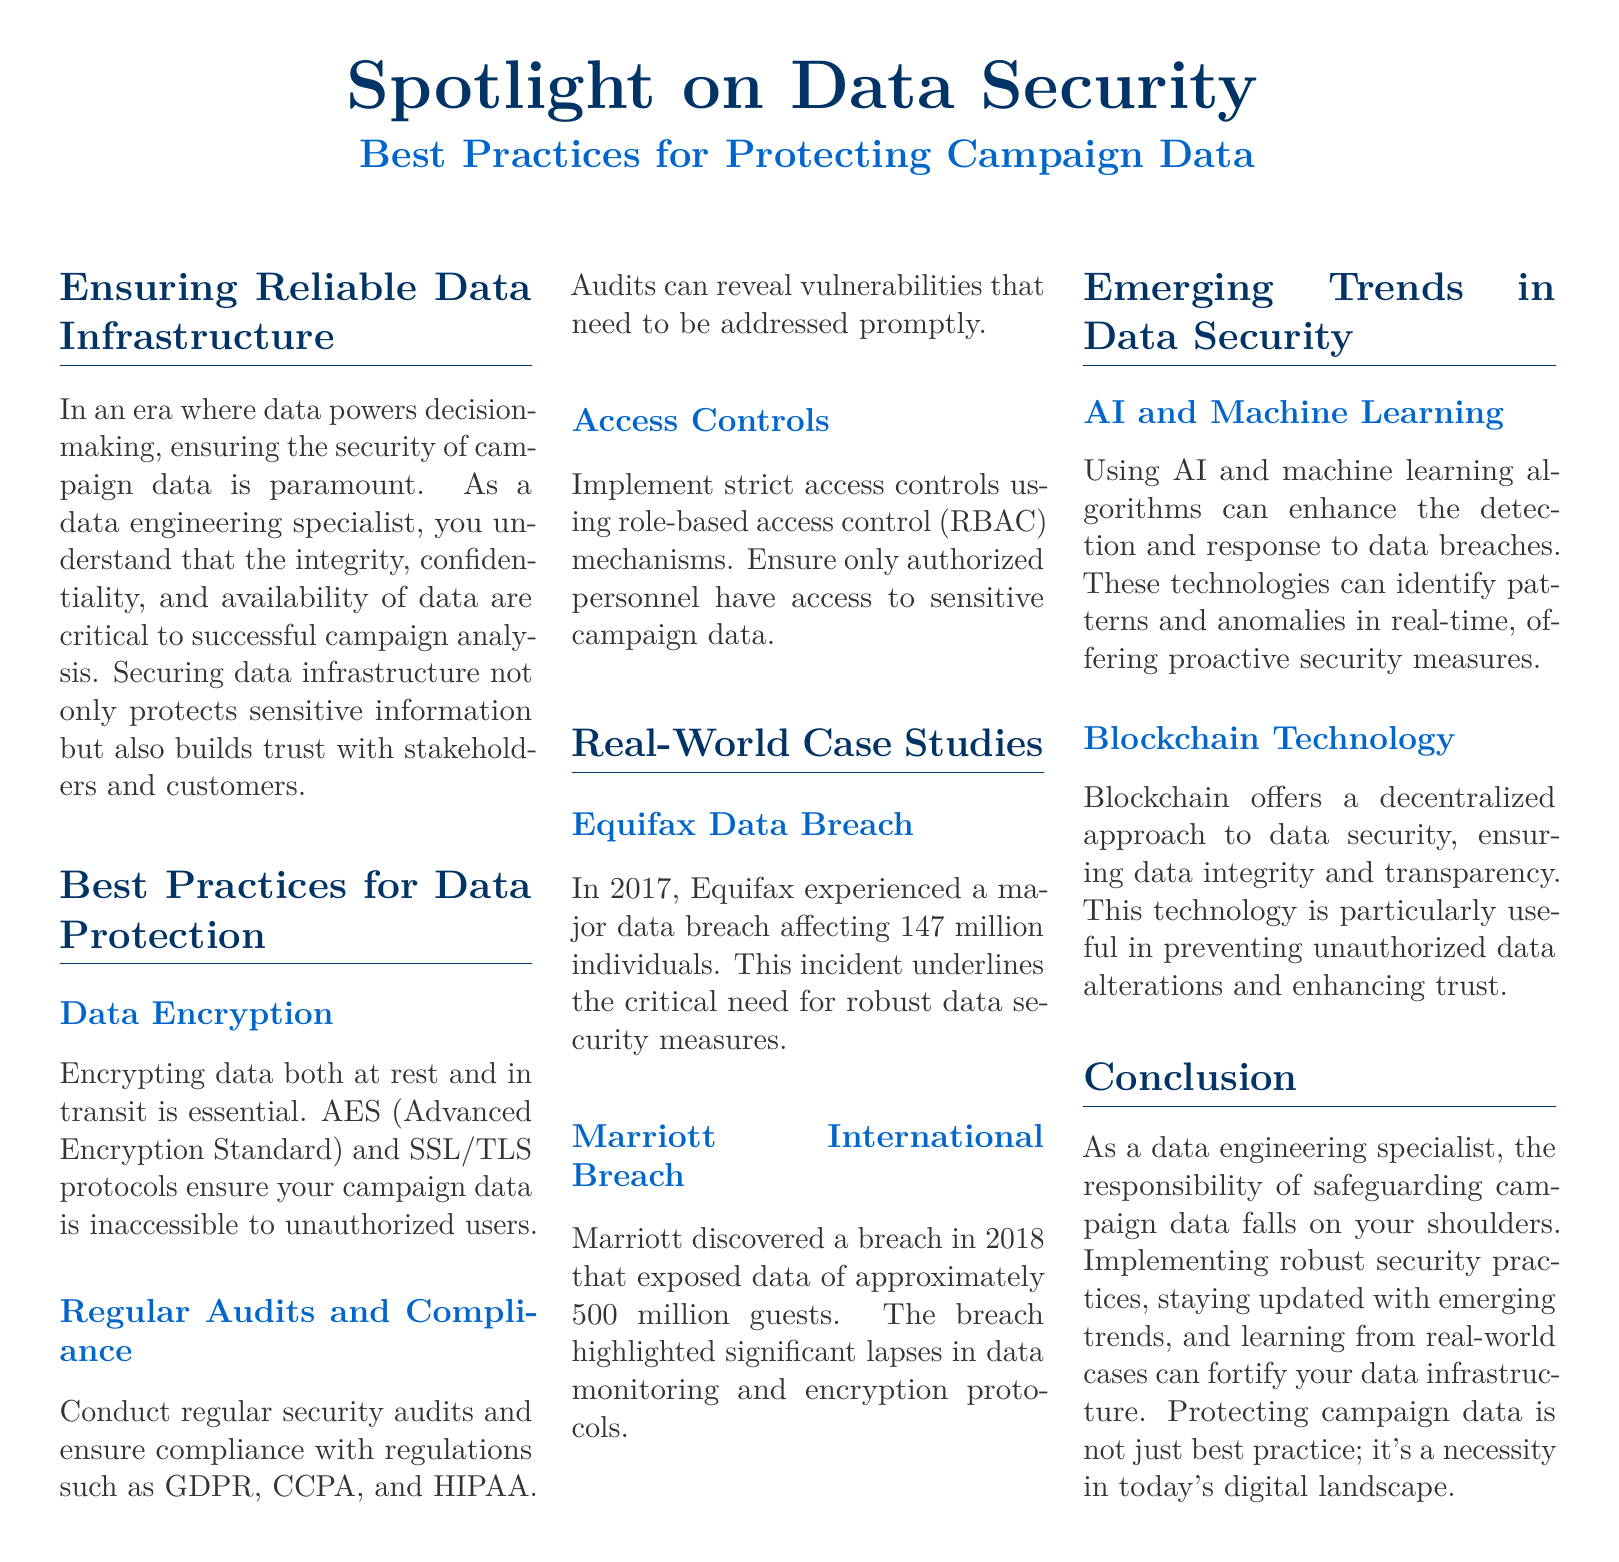What is the main focus of the document? The document centers on data security, specifically best practices for protecting campaign data.
Answer: Data security What encryption standards are mentioned for data protection? The document mentions AES (Advanced Encryption Standard) and SSL/TLS protocols for data encryption.
Answer: AES and SSL/TLS How many individuals were affected by the Equifax data breach? The Equifax data breach in 2017 affected 147 million individuals.
Answer: 147 million What year did the Marriott International breach occur? The breach at Marriott International was discovered in 2018.
Answer: 2018 Which emerging technology is highlighted for enhancing data security? The document mentions AI and machine learning as emerging technologies that can improve detection and response to data breaches.
Answer: AI and machine learning What is one of the compliance regulations noted in the document? The document lists GDPR, CCPA, and HIPAA as regulations for compliance.
Answer: GDPR What type of access control is recommended in the document? The document advises implementing role-based access control (RBAC) for access control.
Answer: Role-based access control What is a primary consequence of the Equifax data breach? The consequence highlighted is the critical need for robust data security measures.
Answer: Need for robust measures What color scheme is used for the document headers? The header colors in the document use a combination of dark blue tones.
Answer: Dark blue 